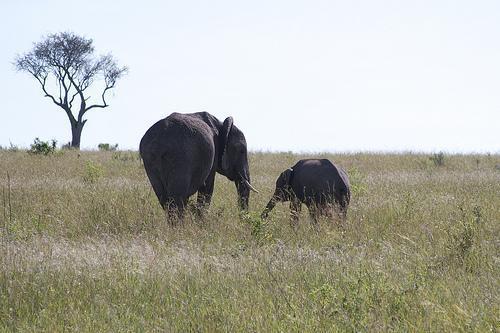How many elephants are there?
Give a very brief answer. 2. 